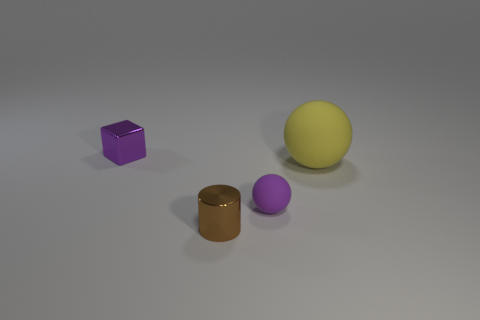The large ball is what color?
Provide a succinct answer. Yellow. There is another yellow object that is the same shape as the small rubber thing; what material is it?
Your answer should be compact. Rubber. Is there anything else that is the same material as the small brown cylinder?
Offer a terse response. Yes. Does the shiny cylinder have the same color as the large rubber ball?
Offer a very short reply. No. What is the shape of the small metallic thing that is to the left of the metal thing to the right of the purple block?
Give a very brief answer. Cube. There is a small object that is the same material as the large ball; what is its shape?
Your response must be concise. Sphere. How many other objects are the same shape as the purple matte thing?
Offer a terse response. 1. Does the metal object right of the purple cube have the same size as the big yellow matte object?
Your answer should be compact. No. Is the number of tiny purple matte things to the right of the big rubber ball greater than the number of small metal cubes?
Offer a terse response. No. There is a metal thing in front of the tiny purple metal thing; how many tiny purple objects are in front of it?
Make the answer very short. 0. 